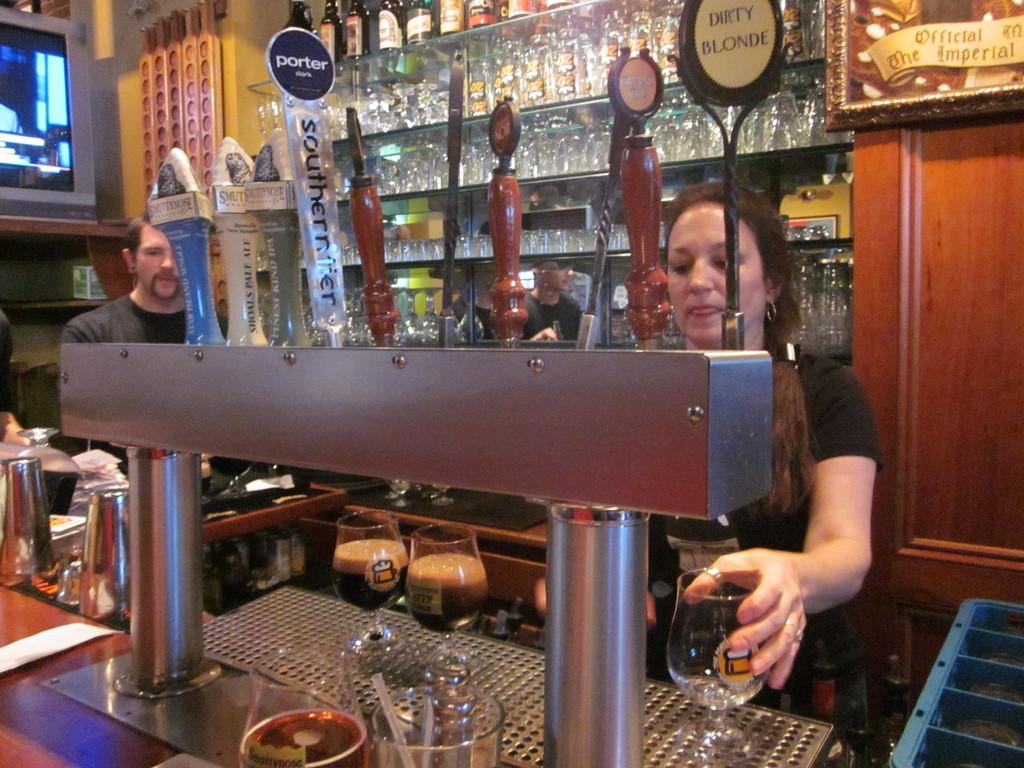<image>
Present a compact description of the photo's key features. A bar has tap signs that say Porter and Dirty Blonde. 